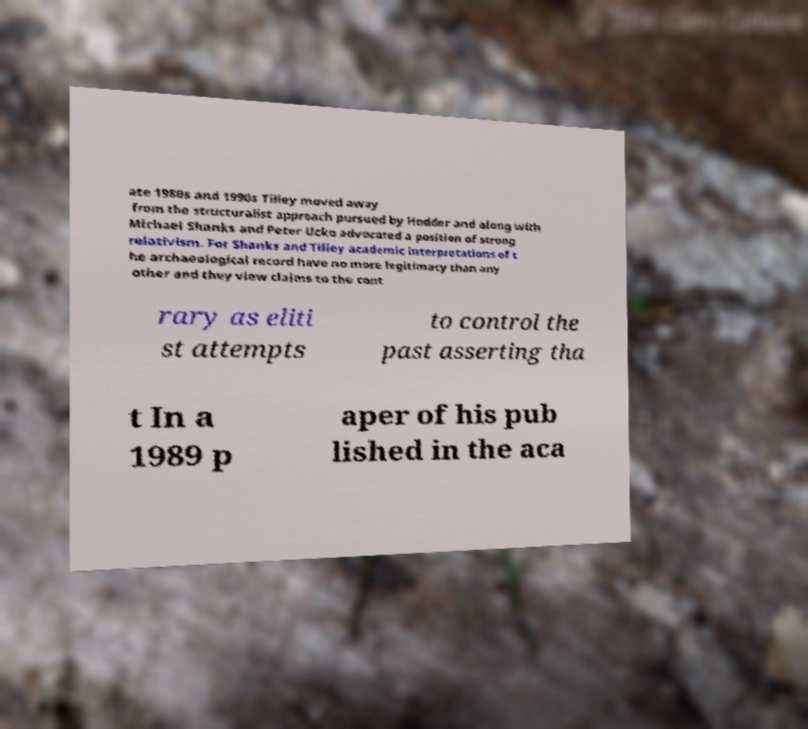Can you read and provide the text displayed in the image?This photo seems to have some interesting text. Can you extract and type it out for me? ate 1980s and 1990s Tilley moved away from the structuralist approach pursued by Hodder and along with Michael Shanks and Peter Ucko advocated a position of strong relativism. For Shanks and Tilley academic interpretations of t he archaeological record have no more legitimacy than any other and they view claims to the cont rary as eliti st attempts to control the past asserting tha t In a 1989 p aper of his pub lished in the aca 